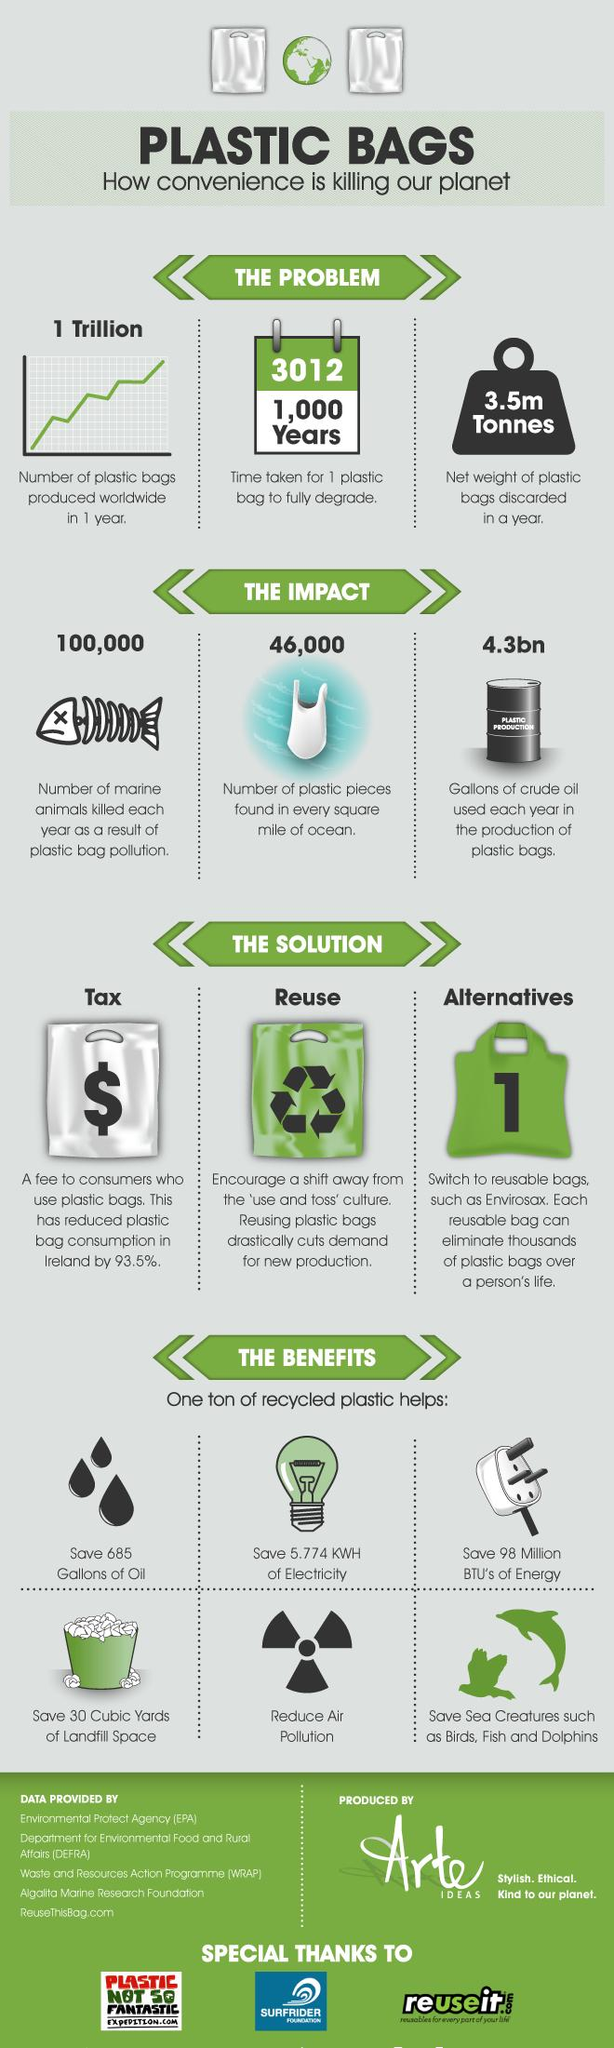Give some essential details in this illustration. The time it takes for one plastic bag to fully degrade is 1,000 years. It is estimated that over one trillion plastic bags are produced worldwide in a single year. According to estimates, approximately 3.5 million metric tons of plastic bags are discarded annually. A 93.5% decrease in plastic bag consumption was observed in Ireland after a fine was imposed for their use. The number of plastic pieces found in every square mile of ocean is 46,000. 